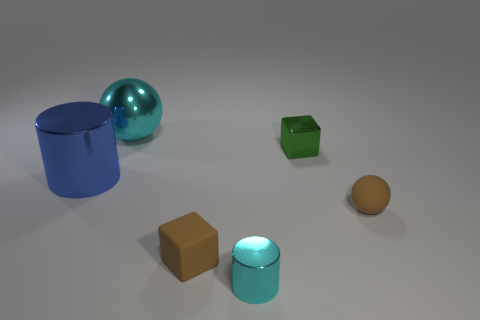Add 2 tiny cyan matte cubes. How many objects exist? 8 Subtract all cyan cylinders. How many cylinders are left? 1 Subtract all yellow balls. Subtract all cyan blocks. How many balls are left? 2 Subtract all large things. Subtract all small brown things. How many objects are left? 2 Add 2 small shiny things. How many small shiny things are left? 4 Add 1 tiny brown blocks. How many tiny brown blocks exist? 2 Subtract 0 gray cylinders. How many objects are left? 6 